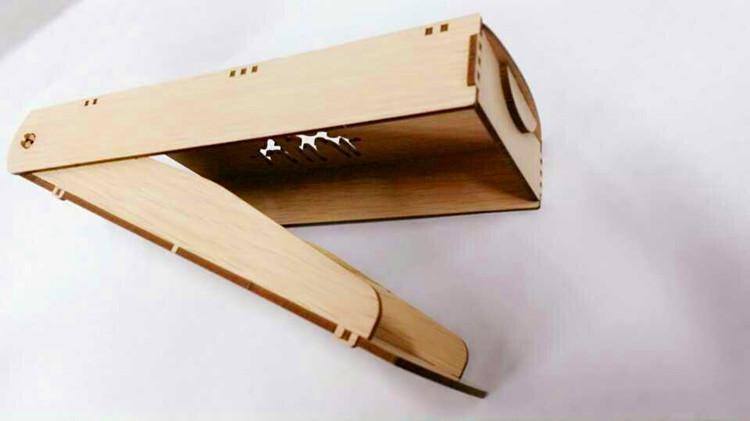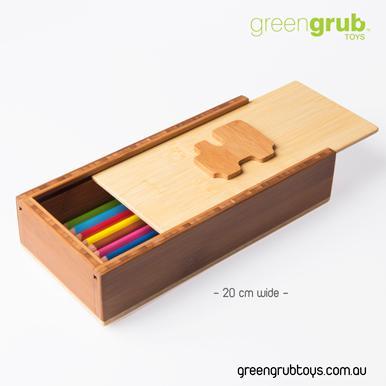The first image is the image on the left, the second image is the image on the right. Evaluate the accuracy of this statement regarding the images: "One of the pencil cases pictured has an Eiffel tower imprint.". Is it true? Answer yes or no. No. The first image is the image on the left, the second image is the image on the right. Evaluate the accuracy of this statement regarding the images: "The case is open in the image on the lef.". Is it true? Answer yes or no. Yes. 